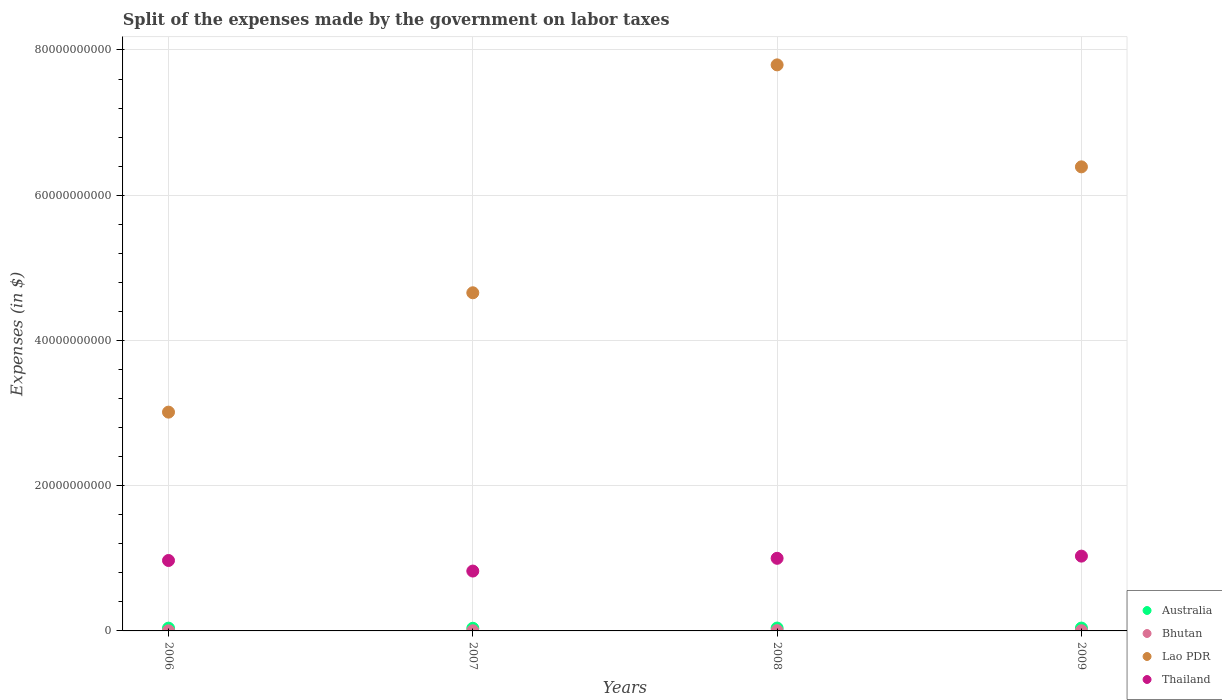What is the expenses made by the government on labor taxes in Thailand in 2006?
Your answer should be very brief. 9.70e+09. Across all years, what is the maximum expenses made by the government on labor taxes in Australia?
Make the answer very short. 3.96e+08. Across all years, what is the minimum expenses made by the government on labor taxes in Australia?
Give a very brief answer. 3.65e+08. In which year was the expenses made by the government on labor taxes in Bhutan minimum?
Offer a very short reply. 2006. What is the total expenses made by the government on labor taxes in Bhutan in the graph?
Keep it short and to the point. 1.01e+08. What is the difference between the expenses made by the government on labor taxes in Australia in 2007 and that in 2009?
Your response must be concise. -2.80e+07. What is the difference between the expenses made by the government on labor taxes in Thailand in 2009 and the expenses made by the government on labor taxes in Australia in 2008?
Your answer should be very brief. 9.90e+09. What is the average expenses made by the government on labor taxes in Australia per year?
Make the answer very short. 3.84e+08. In the year 2006, what is the difference between the expenses made by the government on labor taxes in Australia and expenses made by the government on labor taxes in Lao PDR?
Give a very brief answer. -2.97e+1. In how many years, is the expenses made by the government on labor taxes in Bhutan greater than 40000000000 $?
Ensure brevity in your answer.  0. What is the ratio of the expenses made by the government on labor taxes in Australia in 2007 to that in 2009?
Your response must be concise. 0.93. Is the expenses made by the government on labor taxes in Bhutan in 2008 less than that in 2009?
Make the answer very short. No. What is the difference between the highest and the second highest expenses made by the government on labor taxes in Thailand?
Make the answer very short. 3.00e+08. What is the difference between the highest and the lowest expenses made by the government on labor taxes in Lao PDR?
Give a very brief answer. 4.78e+1. Is it the case that in every year, the sum of the expenses made by the government on labor taxes in Bhutan and expenses made by the government on labor taxes in Lao PDR  is greater than the expenses made by the government on labor taxes in Thailand?
Offer a very short reply. Yes. Does the expenses made by the government on labor taxes in Thailand monotonically increase over the years?
Give a very brief answer. No. Is the expenses made by the government on labor taxes in Bhutan strictly less than the expenses made by the government on labor taxes in Australia over the years?
Ensure brevity in your answer.  Yes. How many dotlines are there?
Offer a terse response. 4. How many years are there in the graph?
Your answer should be compact. 4. Are the values on the major ticks of Y-axis written in scientific E-notation?
Provide a short and direct response. No. Does the graph contain grids?
Keep it short and to the point. Yes. Where does the legend appear in the graph?
Your response must be concise. Bottom right. How are the legend labels stacked?
Offer a terse response. Vertical. What is the title of the graph?
Your response must be concise. Split of the expenses made by the government on labor taxes. What is the label or title of the X-axis?
Your answer should be compact. Years. What is the label or title of the Y-axis?
Your answer should be compact. Expenses (in $). What is the Expenses (in $) of Australia in 2006?
Your answer should be compact. 3.83e+08. What is the Expenses (in $) in Bhutan in 2006?
Give a very brief answer. 1.35e+07. What is the Expenses (in $) of Lao PDR in 2006?
Your response must be concise. 3.01e+1. What is the Expenses (in $) of Thailand in 2006?
Offer a terse response. 9.70e+09. What is the Expenses (in $) of Australia in 2007?
Make the answer very short. 3.65e+08. What is the Expenses (in $) in Bhutan in 2007?
Your answer should be very brief. 2.20e+07. What is the Expenses (in $) in Lao PDR in 2007?
Keep it short and to the point. 4.66e+1. What is the Expenses (in $) of Thailand in 2007?
Your response must be concise. 8.24e+09. What is the Expenses (in $) of Australia in 2008?
Make the answer very short. 3.96e+08. What is the Expenses (in $) in Bhutan in 2008?
Make the answer very short. 3.87e+07. What is the Expenses (in $) in Lao PDR in 2008?
Your answer should be compact. 7.80e+1. What is the Expenses (in $) of Thailand in 2008?
Keep it short and to the point. 1.00e+1. What is the Expenses (in $) of Australia in 2009?
Make the answer very short. 3.93e+08. What is the Expenses (in $) in Bhutan in 2009?
Your answer should be compact. 2.65e+07. What is the Expenses (in $) of Lao PDR in 2009?
Provide a succinct answer. 6.39e+1. What is the Expenses (in $) of Thailand in 2009?
Provide a short and direct response. 1.03e+1. Across all years, what is the maximum Expenses (in $) in Australia?
Offer a very short reply. 3.96e+08. Across all years, what is the maximum Expenses (in $) in Bhutan?
Offer a very short reply. 3.87e+07. Across all years, what is the maximum Expenses (in $) of Lao PDR?
Your answer should be very brief. 7.80e+1. Across all years, what is the maximum Expenses (in $) of Thailand?
Make the answer very short. 1.03e+1. Across all years, what is the minimum Expenses (in $) in Australia?
Provide a short and direct response. 3.65e+08. Across all years, what is the minimum Expenses (in $) in Bhutan?
Provide a succinct answer. 1.35e+07. Across all years, what is the minimum Expenses (in $) in Lao PDR?
Your answer should be compact. 3.01e+1. Across all years, what is the minimum Expenses (in $) in Thailand?
Give a very brief answer. 8.24e+09. What is the total Expenses (in $) of Australia in the graph?
Make the answer very short. 1.54e+09. What is the total Expenses (in $) of Bhutan in the graph?
Provide a short and direct response. 1.01e+08. What is the total Expenses (in $) of Lao PDR in the graph?
Make the answer very short. 2.19e+11. What is the total Expenses (in $) of Thailand in the graph?
Provide a short and direct response. 3.82e+1. What is the difference between the Expenses (in $) of Australia in 2006 and that in 2007?
Your answer should be compact. 1.80e+07. What is the difference between the Expenses (in $) in Bhutan in 2006 and that in 2007?
Make the answer very short. -8.59e+06. What is the difference between the Expenses (in $) of Lao PDR in 2006 and that in 2007?
Ensure brevity in your answer.  -1.64e+1. What is the difference between the Expenses (in $) in Thailand in 2006 and that in 2007?
Ensure brevity in your answer.  1.46e+09. What is the difference between the Expenses (in $) in Australia in 2006 and that in 2008?
Ensure brevity in your answer.  -1.30e+07. What is the difference between the Expenses (in $) of Bhutan in 2006 and that in 2008?
Your answer should be compact. -2.52e+07. What is the difference between the Expenses (in $) of Lao PDR in 2006 and that in 2008?
Your response must be concise. -4.78e+1. What is the difference between the Expenses (in $) of Thailand in 2006 and that in 2008?
Ensure brevity in your answer.  -3.01e+08. What is the difference between the Expenses (in $) of Australia in 2006 and that in 2009?
Offer a terse response. -1.00e+07. What is the difference between the Expenses (in $) in Bhutan in 2006 and that in 2009?
Provide a short and direct response. -1.30e+07. What is the difference between the Expenses (in $) of Lao PDR in 2006 and that in 2009?
Your answer should be compact. -3.38e+1. What is the difference between the Expenses (in $) of Thailand in 2006 and that in 2009?
Provide a short and direct response. -6.01e+08. What is the difference between the Expenses (in $) in Australia in 2007 and that in 2008?
Your answer should be very brief. -3.10e+07. What is the difference between the Expenses (in $) of Bhutan in 2007 and that in 2008?
Your answer should be compact. -1.66e+07. What is the difference between the Expenses (in $) of Lao PDR in 2007 and that in 2008?
Your response must be concise. -3.14e+1. What is the difference between the Expenses (in $) of Thailand in 2007 and that in 2008?
Your answer should be compact. -1.76e+09. What is the difference between the Expenses (in $) of Australia in 2007 and that in 2009?
Your answer should be compact. -2.80e+07. What is the difference between the Expenses (in $) of Bhutan in 2007 and that in 2009?
Give a very brief answer. -4.44e+06. What is the difference between the Expenses (in $) in Lao PDR in 2007 and that in 2009?
Your answer should be compact. -1.73e+1. What is the difference between the Expenses (in $) of Thailand in 2007 and that in 2009?
Keep it short and to the point. -2.06e+09. What is the difference between the Expenses (in $) of Australia in 2008 and that in 2009?
Keep it short and to the point. 3.00e+06. What is the difference between the Expenses (in $) of Bhutan in 2008 and that in 2009?
Offer a terse response. 1.22e+07. What is the difference between the Expenses (in $) in Lao PDR in 2008 and that in 2009?
Provide a short and direct response. 1.40e+1. What is the difference between the Expenses (in $) of Thailand in 2008 and that in 2009?
Your answer should be very brief. -3.00e+08. What is the difference between the Expenses (in $) of Australia in 2006 and the Expenses (in $) of Bhutan in 2007?
Your answer should be very brief. 3.61e+08. What is the difference between the Expenses (in $) of Australia in 2006 and the Expenses (in $) of Lao PDR in 2007?
Your answer should be compact. -4.62e+1. What is the difference between the Expenses (in $) of Australia in 2006 and the Expenses (in $) of Thailand in 2007?
Provide a short and direct response. -7.86e+09. What is the difference between the Expenses (in $) of Bhutan in 2006 and the Expenses (in $) of Lao PDR in 2007?
Your answer should be compact. -4.66e+1. What is the difference between the Expenses (in $) in Bhutan in 2006 and the Expenses (in $) in Thailand in 2007?
Your response must be concise. -8.23e+09. What is the difference between the Expenses (in $) of Lao PDR in 2006 and the Expenses (in $) of Thailand in 2007?
Give a very brief answer. 2.19e+1. What is the difference between the Expenses (in $) of Australia in 2006 and the Expenses (in $) of Bhutan in 2008?
Provide a short and direct response. 3.44e+08. What is the difference between the Expenses (in $) in Australia in 2006 and the Expenses (in $) in Lao PDR in 2008?
Provide a short and direct response. -7.76e+1. What is the difference between the Expenses (in $) in Australia in 2006 and the Expenses (in $) in Thailand in 2008?
Make the answer very short. -9.62e+09. What is the difference between the Expenses (in $) of Bhutan in 2006 and the Expenses (in $) of Lao PDR in 2008?
Make the answer very short. -7.79e+1. What is the difference between the Expenses (in $) in Bhutan in 2006 and the Expenses (in $) in Thailand in 2008?
Keep it short and to the point. -9.99e+09. What is the difference between the Expenses (in $) of Lao PDR in 2006 and the Expenses (in $) of Thailand in 2008?
Make the answer very short. 2.01e+1. What is the difference between the Expenses (in $) in Australia in 2006 and the Expenses (in $) in Bhutan in 2009?
Provide a short and direct response. 3.57e+08. What is the difference between the Expenses (in $) of Australia in 2006 and the Expenses (in $) of Lao PDR in 2009?
Offer a terse response. -6.35e+1. What is the difference between the Expenses (in $) in Australia in 2006 and the Expenses (in $) in Thailand in 2009?
Provide a succinct answer. -9.92e+09. What is the difference between the Expenses (in $) of Bhutan in 2006 and the Expenses (in $) of Lao PDR in 2009?
Give a very brief answer. -6.39e+1. What is the difference between the Expenses (in $) in Bhutan in 2006 and the Expenses (in $) in Thailand in 2009?
Provide a short and direct response. -1.03e+1. What is the difference between the Expenses (in $) in Lao PDR in 2006 and the Expenses (in $) in Thailand in 2009?
Your answer should be compact. 1.98e+1. What is the difference between the Expenses (in $) in Australia in 2007 and the Expenses (in $) in Bhutan in 2008?
Offer a terse response. 3.26e+08. What is the difference between the Expenses (in $) of Australia in 2007 and the Expenses (in $) of Lao PDR in 2008?
Ensure brevity in your answer.  -7.76e+1. What is the difference between the Expenses (in $) in Australia in 2007 and the Expenses (in $) in Thailand in 2008?
Keep it short and to the point. -9.64e+09. What is the difference between the Expenses (in $) in Bhutan in 2007 and the Expenses (in $) in Lao PDR in 2008?
Your answer should be compact. -7.79e+1. What is the difference between the Expenses (in $) in Bhutan in 2007 and the Expenses (in $) in Thailand in 2008?
Offer a very short reply. -9.98e+09. What is the difference between the Expenses (in $) of Lao PDR in 2007 and the Expenses (in $) of Thailand in 2008?
Make the answer very short. 3.66e+1. What is the difference between the Expenses (in $) of Australia in 2007 and the Expenses (in $) of Bhutan in 2009?
Your answer should be very brief. 3.39e+08. What is the difference between the Expenses (in $) of Australia in 2007 and the Expenses (in $) of Lao PDR in 2009?
Ensure brevity in your answer.  -6.35e+1. What is the difference between the Expenses (in $) in Australia in 2007 and the Expenses (in $) in Thailand in 2009?
Give a very brief answer. -9.94e+09. What is the difference between the Expenses (in $) in Bhutan in 2007 and the Expenses (in $) in Lao PDR in 2009?
Offer a very short reply. -6.39e+1. What is the difference between the Expenses (in $) of Bhutan in 2007 and the Expenses (in $) of Thailand in 2009?
Make the answer very short. -1.03e+1. What is the difference between the Expenses (in $) of Lao PDR in 2007 and the Expenses (in $) of Thailand in 2009?
Ensure brevity in your answer.  3.63e+1. What is the difference between the Expenses (in $) in Australia in 2008 and the Expenses (in $) in Bhutan in 2009?
Offer a very short reply. 3.70e+08. What is the difference between the Expenses (in $) in Australia in 2008 and the Expenses (in $) in Lao PDR in 2009?
Provide a succinct answer. -6.35e+1. What is the difference between the Expenses (in $) of Australia in 2008 and the Expenses (in $) of Thailand in 2009?
Offer a terse response. -9.90e+09. What is the difference between the Expenses (in $) in Bhutan in 2008 and the Expenses (in $) in Lao PDR in 2009?
Ensure brevity in your answer.  -6.39e+1. What is the difference between the Expenses (in $) in Bhutan in 2008 and the Expenses (in $) in Thailand in 2009?
Offer a very short reply. -1.03e+1. What is the difference between the Expenses (in $) in Lao PDR in 2008 and the Expenses (in $) in Thailand in 2009?
Keep it short and to the point. 6.77e+1. What is the average Expenses (in $) of Australia per year?
Ensure brevity in your answer.  3.84e+08. What is the average Expenses (in $) in Bhutan per year?
Make the answer very short. 2.52e+07. What is the average Expenses (in $) in Lao PDR per year?
Provide a short and direct response. 5.46e+1. What is the average Expenses (in $) in Thailand per year?
Offer a terse response. 9.56e+09. In the year 2006, what is the difference between the Expenses (in $) in Australia and Expenses (in $) in Bhutan?
Your response must be concise. 3.70e+08. In the year 2006, what is the difference between the Expenses (in $) in Australia and Expenses (in $) in Lao PDR?
Provide a succinct answer. -2.97e+1. In the year 2006, what is the difference between the Expenses (in $) of Australia and Expenses (in $) of Thailand?
Your answer should be very brief. -9.32e+09. In the year 2006, what is the difference between the Expenses (in $) of Bhutan and Expenses (in $) of Lao PDR?
Offer a terse response. -3.01e+1. In the year 2006, what is the difference between the Expenses (in $) in Bhutan and Expenses (in $) in Thailand?
Provide a short and direct response. -9.69e+09. In the year 2006, what is the difference between the Expenses (in $) in Lao PDR and Expenses (in $) in Thailand?
Offer a terse response. 2.04e+1. In the year 2007, what is the difference between the Expenses (in $) in Australia and Expenses (in $) in Bhutan?
Keep it short and to the point. 3.43e+08. In the year 2007, what is the difference between the Expenses (in $) in Australia and Expenses (in $) in Lao PDR?
Your answer should be very brief. -4.62e+1. In the year 2007, what is the difference between the Expenses (in $) of Australia and Expenses (in $) of Thailand?
Provide a succinct answer. -7.88e+09. In the year 2007, what is the difference between the Expenses (in $) of Bhutan and Expenses (in $) of Lao PDR?
Ensure brevity in your answer.  -4.65e+1. In the year 2007, what is the difference between the Expenses (in $) in Bhutan and Expenses (in $) in Thailand?
Give a very brief answer. -8.22e+09. In the year 2007, what is the difference between the Expenses (in $) of Lao PDR and Expenses (in $) of Thailand?
Provide a succinct answer. 3.83e+1. In the year 2008, what is the difference between the Expenses (in $) in Australia and Expenses (in $) in Bhutan?
Give a very brief answer. 3.57e+08. In the year 2008, what is the difference between the Expenses (in $) of Australia and Expenses (in $) of Lao PDR?
Your answer should be very brief. -7.76e+1. In the year 2008, what is the difference between the Expenses (in $) of Australia and Expenses (in $) of Thailand?
Your response must be concise. -9.60e+09. In the year 2008, what is the difference between the Expenses (in $) in Bhutan and Expenses (in $) in Lao PDR?
Give a very brief answer. -7.79e+1. In the year 2008, what is the difference between the Expenses (in $) in Bhutan and Expenses (in $) in Thailand?
Make the answer very short. -9.96e+09. In the year 2008, what is the difference between the Expenses (in $) in Lao PDR and Expenses (in $) in Thailand?
Ensure brevity in your answer.  6.80e+1. In the year 2009, what is the difference between the Expenses (in $) in Australia and Expenses (in $) in Bhutan?
Your answer should be compact. 3.67e+08. In the year 2009, what is the difference between the Expenses (in $) in Australia and Expenses (in $) in Lao PDR?
Ensure brevity in your answer.  -6.35e+1. In the year 2009, what is the difference between the Expenses (in $) of Australia and Expenses (in $) of Thailand?
Provide a succinct answer. -9.91e+09. In the year 2009, what is the difference between the Expenses (in $) of Bhutan and Expenses (in $) of Lao PDR?
Make the answer very short. -6.39e+1. In the year 2009, what is the difference between the Expenses (in $) of Bhutan and Expenses (in $) of Thailand?
Give a very brief answer. -1.03e+1. In the year 2009, what is the difference between the Expenses (in $) in Lao PDR and Expenses (in $) in Thailand?
Offer a very short reply. 5.36e+1. What is the ratio of the Expenses (in $) of Australia in 2006 to that in 2007?
Make the answer very short. 1.05. What is the ratio of the Expenses (in $) in Bhutan in 2006 to that in 2007?
Your answer should be compact. 0.61. What is the ratio of the Expenses (in $) of Lao PDR in 2006 to that in 2007?
Your answer should be compact. 0.65. What is the ratio of the Expenses (in $) in Thailand in 2006 to that in 2007?
Provide a short and direct response. 1.18. What is the ratio of the Expenses (in $) of Australia in 2006 to that in 2008?
Keep it short and to the point. 0.97. What is the ratio of the Expenses (in $) of Bhutan in 2006 to that in 2008?
Provide a short and direct response. 0.35. What is the ratio of the Expenses (in $) of Lao PDR in 2006 to that in 2008?
Offer a very short reply. 0.39. What is the ratio of the Expenses (in $) of Thailand in 2006 to that in 2008?
Your response must be concise. 0.97. What is the ratio of the Expenses (in $) of Australia in 2006 to that in 2009?
Offer a very short reply. 0.97. What is the ratio of the Expenses (in $) of Bhutan in 2006 to that in 2009?
Keep it short and to the point. 0.51. What is the ratio of the Expenses (in $) in Lao PDR in 2006 to that in 2009?
Make the answer very short. 0.47. What is the ratio of the Expenses (in $) in Thailand in 2006 to that in 2009?
Ensure brevity in your answer.  0.94. What is the ratio of the Expenses (in $) of Australia in 2007 to that in 2008?
Your answer should be compact. 0.92. What is the ratio of the Expenses (in $) in Bhutan in 2007 to that in 2008?
Provide a short and direct response. 0.57. What is the ratio of the Expenses (in $) in Lao PDR in 2007 to that in 2008?
Offer a very short reply. 0.6. What is the ratio of the Expenses (in $) of Thailand in 2007 to that in 2008?
Keep it short and to the point. 0.82. What is the ratio of the Expenses (in $) in Australia in 2007 to that in 2009?
Keep it short and to the point. 0.93. What is the ratio of the Expenses (in $) of Bhutan in 2007 to that in 2009?
Your answer should be very brief. 0.83. What is the ratio of the Expenses (in $) in Lao PDR in 2007 to that in 2009?
Provide a short and direct response. 0.73. What is the ratio of the Expenses (in $) in Thailand in 2007 to that in 2009?
Offer a very short reply. 0.8. What is the ratio of the Expenses (in $) in Australia in 2008 to that in 2009?
Your response must be concise. 1.01. What is the ratio of the Expenses (in $) in Bhutan in 2008 to that in 2009?
Your answer should be very brief. 1.46. What is the ratio of the Expenses (in $) in Lao PDR in 2008 to that in 2009?
Provide a short and direct response. 1.22. What is the ratio of the Expenses (in $) of Thailand in 2008 to that in 2009?
Ensure brevity in your answer.  0.97. What is the difference between the highest and the second highest Expenses (in $) of Australia?
Keep it short and to the point. 3.00e+06. What is the difference between the highest and the second highest Expenses (in $) in Bhutan?
Make the answer very short. 1.22e+07. What is the difference between the highest and the second highest Expenses (in $) in Lao PDR?
Provide a succinct answer. 1.40e+1. What is the difference between the highest and the second highest Expenses (in $) of Thailand?
Keep it short and to the point. 3.00e+08. What is the difference between the highest and the lowest Expenses (in $) in Australia?
Provide a short and direct response. 3.10e+07. What is the difference between the highest and the lowest Expenses (in $) of Bhutan?
Your answer should be compact. 2.52e+07. What is the difference between the highest and the lowest Expenses (in $) in Lao PDR?
Provide a short and direct response. 4.78e+1. What is the difference between the highest and the lowest Expenses (in $) in Thailand?
Give a very brief answer. 2.06e+09. 